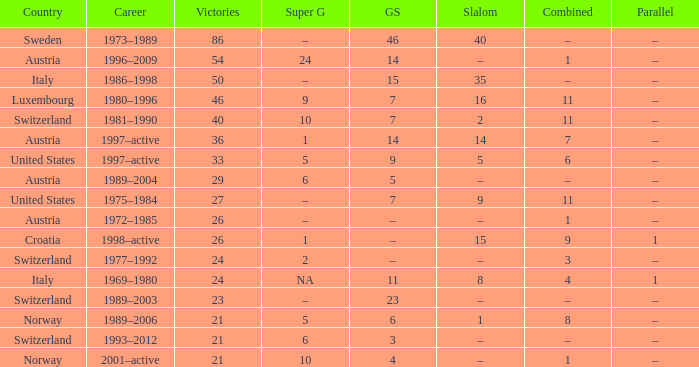What Super G has a Career of 1980–1996? 9.0. 